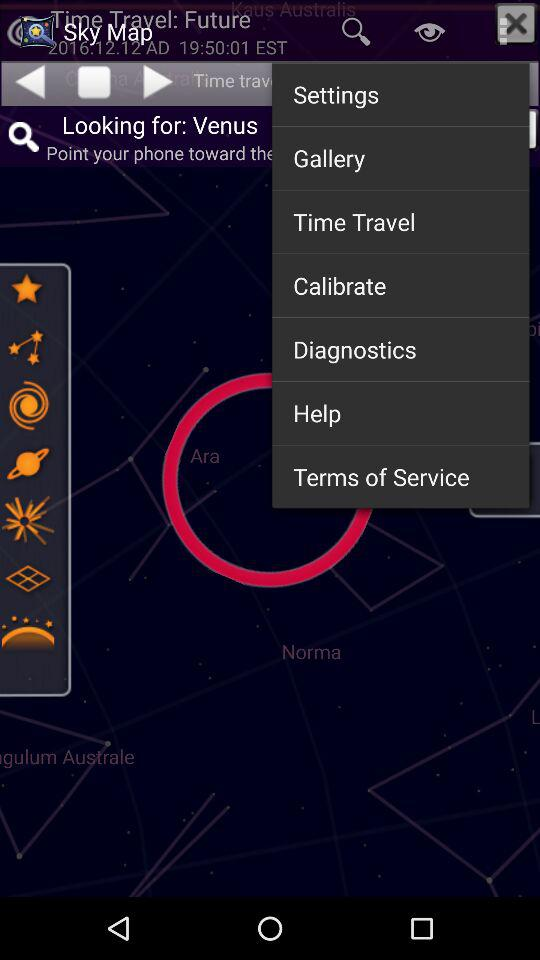What is the application name? The application name is "Sky Map". 